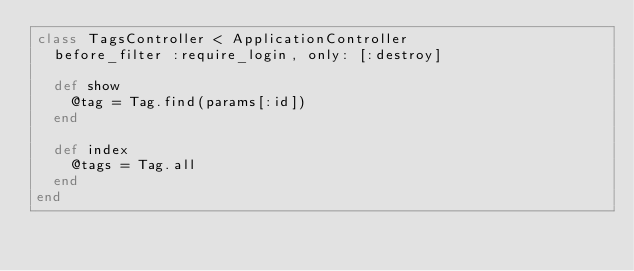<code> <loc_0><loc_0><loc_500><loc_500><_Ruby_>class TagsController < ApplicationController
  before_filter :require_login, only: [:destroy]

  def show
    @tag = Tag.find(params[:id])
  end

  def index
    @tags = Tag.all
  end
end
</code> 